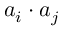Convert formula to latex. <formula><loc_0><loc_0><loc_500><loc_500>a _ { i } \cdot a _ { j }</formula> 